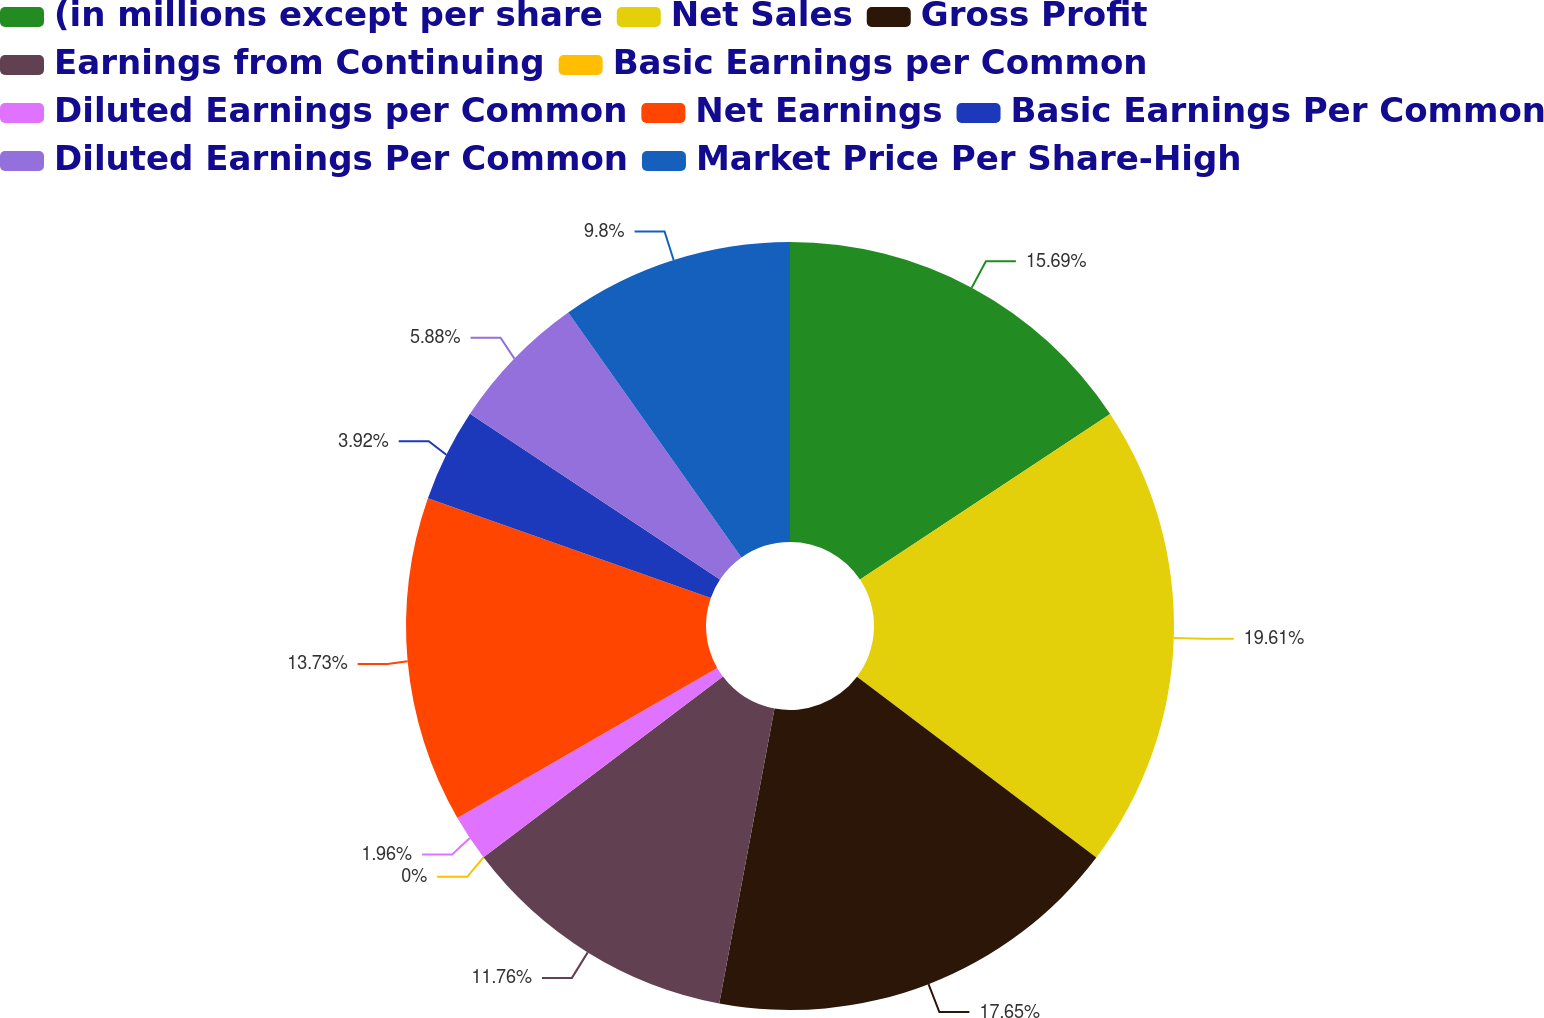Convert chart. <chart><loc_0><loc_0><loc_500><loc_500><pie_chart><fcel>(in millions except per share<fcel>Net Sales<fcel>Gross Profit<fcel>Earnings from Continuing<fcel>Basic Earnings per Common<fcel>Diluted Earnings per Common<fcel>Net Earnings<fcel>Basic Earnings Per Common<fcel>Diluted Earnings Per Common<fcel>Market Price Per Share-High<nl><fcel>15.69%<fcel>19.61%<fcel>17.65%<fcel>11.76%<fcel>0.0%<fcel>1.96%<fcel>13.73%<fcel>3.92%<fcel>5.88%<fcel>9.8%<nl></chart> 